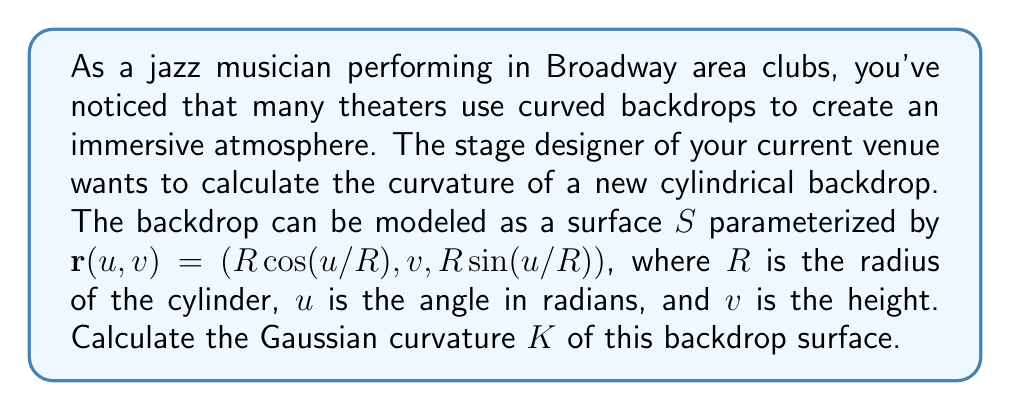Solve this math problem. To calculate the Gaussian curvature of the cylindrical backdrop, we'll follow these steps:

1) First, we need to calculate the partial derivatives of $\mathbf{r}$ with respect to $u$ and $v$:

   $$\mathbf{r}_u = (-\sin(u/R), 0, \cos(u/R))$$
   $$\mathbf{r}_v = (0, 1, 0)$$

2) Next, we calculate the second partial derivatives:

   $$\mathbf{r}_{uu} = (-\cos(u/R)/R, 0, -\sin(u/R)/R)$$
   $$\mathbf{r}_{uv} = \mathbf{r}_{vu} = (0, 0, 0)$$
   $$\mathbf{r}_{vv} = (0, 0, 0)$$

3) Now we can compute the coefficients of the first fundamental form:

   $$E = \mathbf{r}_u \cdot \mathbf{r}_u = 1$$
   $$F = \mathbf{r}_u \cdot \mathbf{r}_v = 0$$
   $$G = \mathbf{r}_v \cdot \mathbf{r}_v = 1$$

4) And the coefficients of the second fundamental form:

   $$\mathbf{n} = \frac{\mathbf{r}_u \times \mathbf{r}_v}{|\mathbf{r}_u \times \mathbf{r}_v|} = (\cos(u/R), 0, \sin(u/R))$$

   $$L = \mathbf{r}_{uu} \cdot \mathbf{n} = -1/R$$
   $$M = \mathbf{r}_{uv} \cdot \mathbf{n} = 0$$
   $$N = \mathbf{r}_{vv} \cdot \mathbf{n} = 0$$

5) The Gaussian curvature is given by:

   $$K = \frac{LN - M^2}{EG - F^2}$$

6) Substituting our calculated values:

   $$K = \frac{(-1/R)(0) - 0^2}{(1)(1) - 0^2} = 0$$

Therefore, the Gaussian curvature of the cylindrical backdrop is 0.
Answer: The Gaussian curvature $K$ of the cylindrical backdrop is 0. 